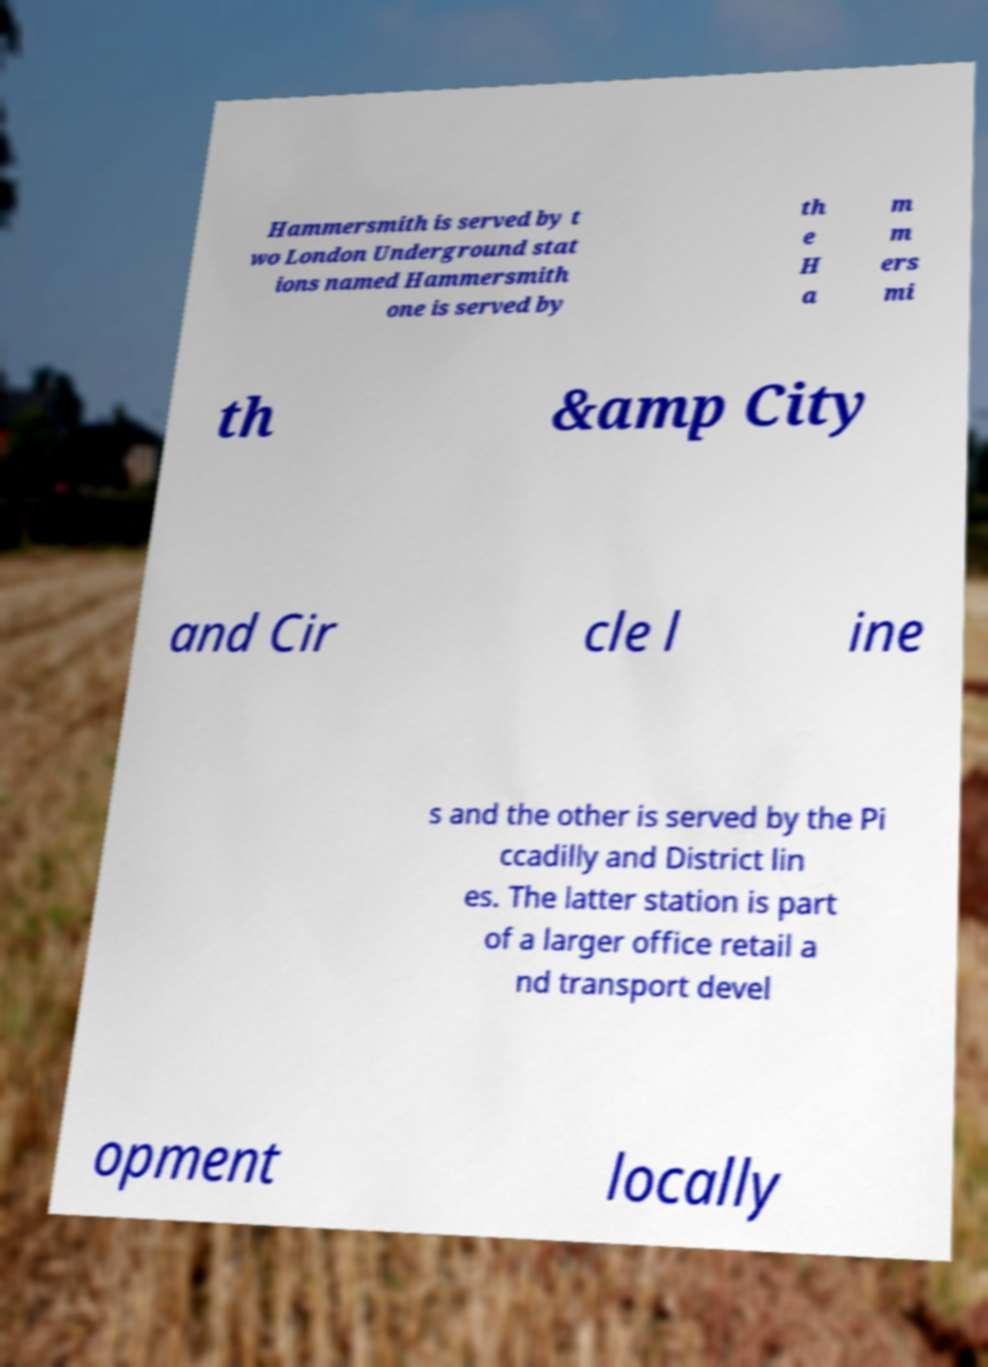Could you assist in decoding the text presented in this image and type it out clearly? Hammersmith is served by t wo London Underground stat ions named Hammersmith one is served by th e H a m m ers mi th &amp City and Cir cle l ine s and the other is served by the Pi ccadilly and District lin es. The latter station is part of a larger office retail a nd transport devel opment locally 